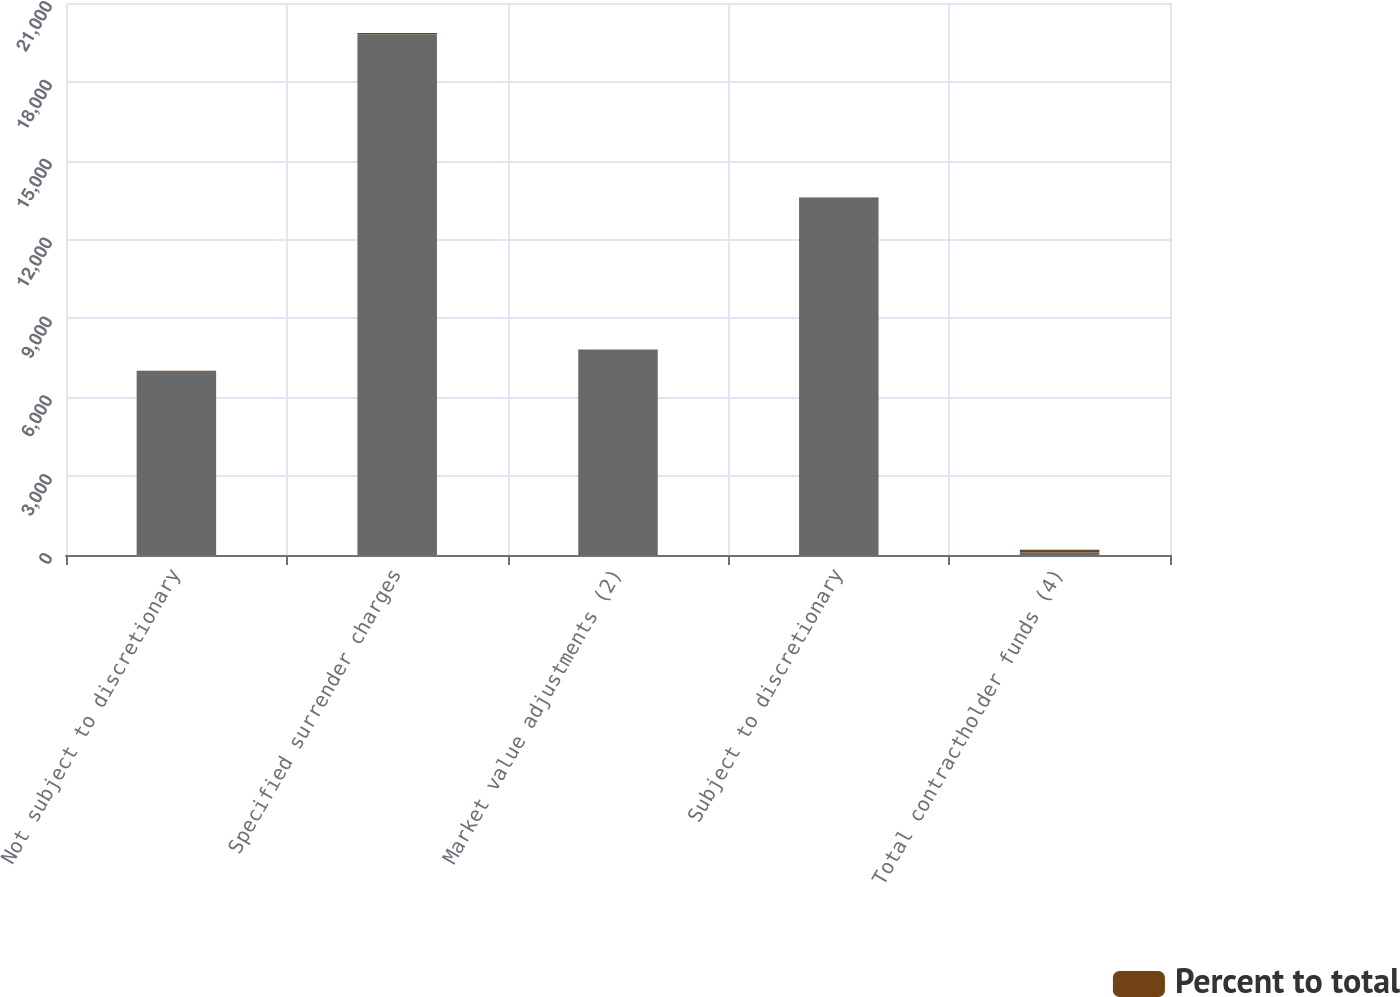Convert chart. <chart><loc_0><loc_0><loc_500><loc_500><stacked_bar_chart><ecel><fcel>Not subject to discretionary<fcel>Specified surrender charges<fcel>Market value adjustments (2)<fcel>Subject to discretionary<fcel>Total contractholder funds (4)<nl><fcel>nan<fcel>6998<fcel>19815<fcel>7805<fcel>13577<fcel>100<nl><fcel>Percent to total<fcel>14.5<fcel>41.1<fcel>16.2<fcel>28.2<fcel>100<nl></chart> 